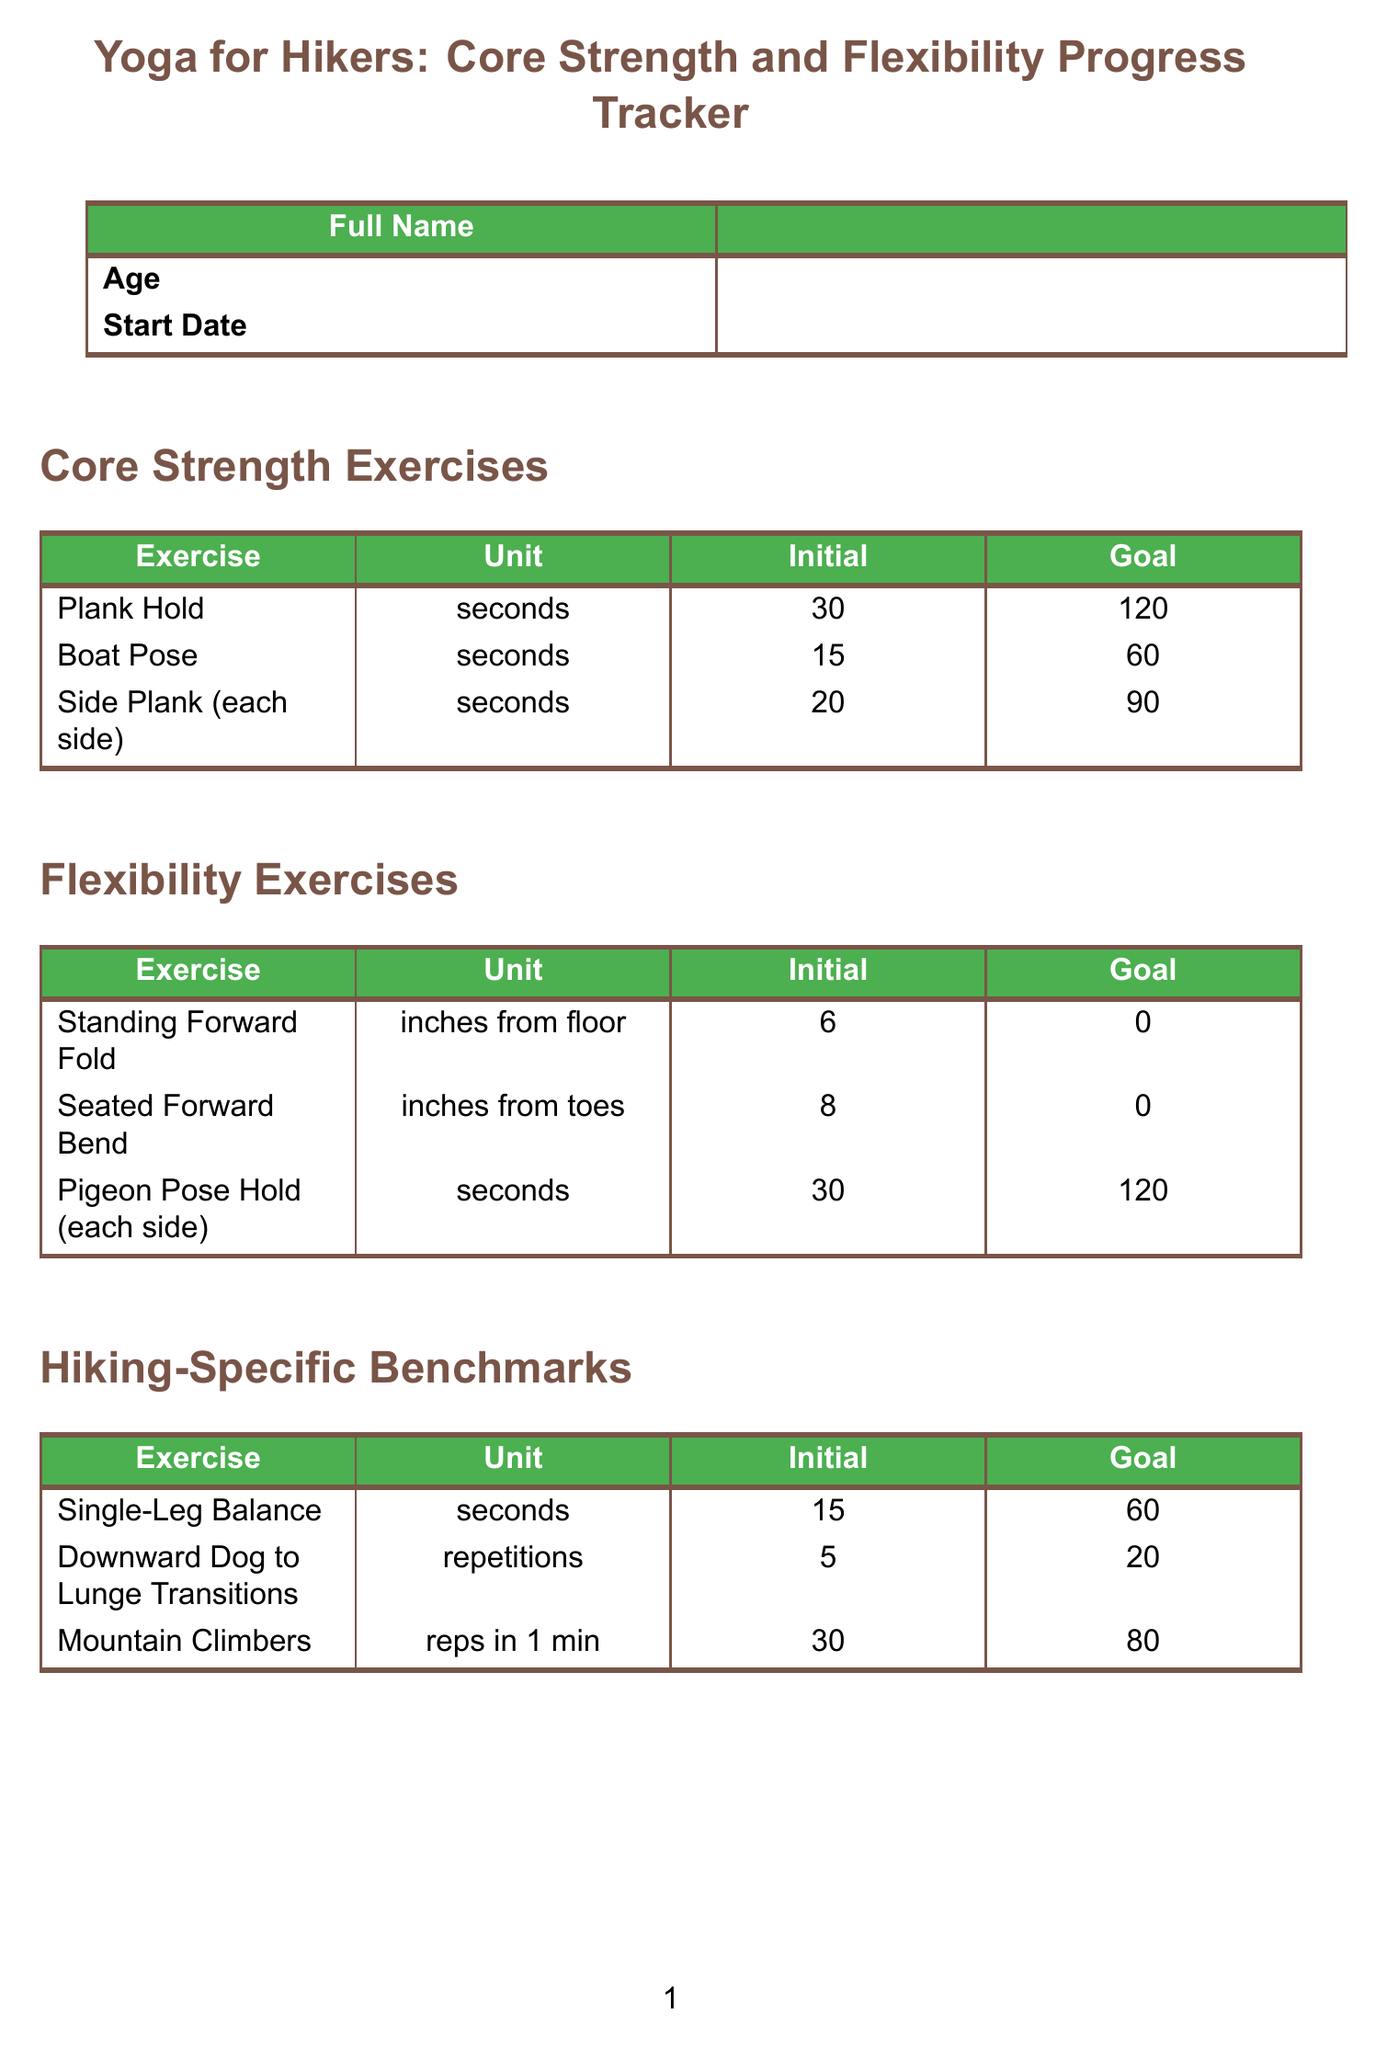what is the title of the document? The title of the document is prominently displayed at the beginning and indicates the purpose of the form.
Answer: Yoga for Hikers: Core Strength and Flexibility Progress Tracker how many seconds is the initial benchmark for the Plank Hold exercise? The initial benchmark for the Plank Hold exercise is mentioned in the Core Strength Exercises section.
Answer: 30 seconds what is the goal benchmark for Side Plank exercises? The goal benchmark for Side Plank exercises is found in the Core Strength Exercises section and indicates the target performance level.
Answer: 90 seconds how many repetitions of Mountain Climbers are needed for the goal benchmark? The goal benchmark for Mountain Climbers is stated in the Hiking-Specific Benchmarks section, specifying the target amount.
Answer: 80 repetitions what unit is used to measure the flexibility for the Standing Forward Fold exercise? The unit used for measuring flexibility in the Standing Forward Fold exercise is specified in the Flexibility Exercises section of the document.
Answer: inches from floor what is the perceived exertion rating scale mentioned in the document? The perceived exertion is rated on a scale and the specific range is provided in the Hiking Performance section of the form.
Answer: 1-10 what are the core stability rating options in the hiking performance section? The core stability rating options are clearly indicated in the Hiking Performance section as part of the assessment.
Answer: 1-10 how many total core strength exercises are listed in the document? The number of core strength exercises is noted in the Core Strength Exercises section where they are outlined.
Answer: 3 exercises what field is included for additional comments about progress? The specific field that allows for further commentary on yoga progress is mentioned in the Additional Notes section of the form.
Answer: Notes on Progress and Observations 